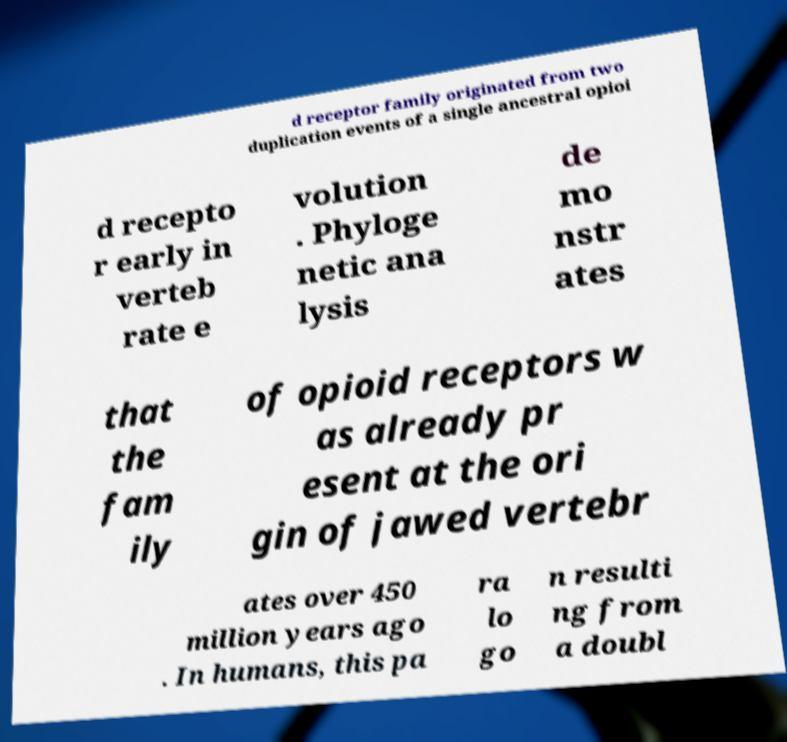What messages or text are displayed in this image? I need them in a readable, typed format. d receptor family originated from two duplication events of a single ancestral opioi d recepto r early in verteb rate e volution . Phyloge netic ana lysis de mo nstr ates that the fam ily of opioid receptors w as already pr esent at the ori gin of jawed vertebr ates over 450 million years ago . In humans, this pa ra lo go n resulti ng from a doubl 